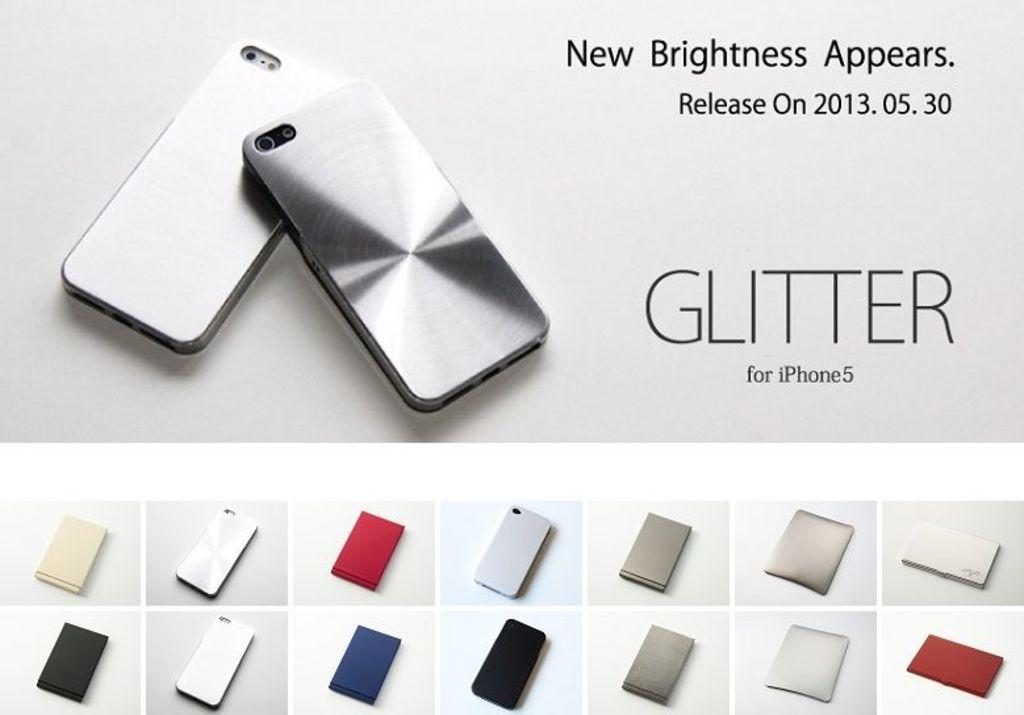<image>
Create a compact narrative representing the image presented. A phone advertisement for Glitter cases for the Iphone. 